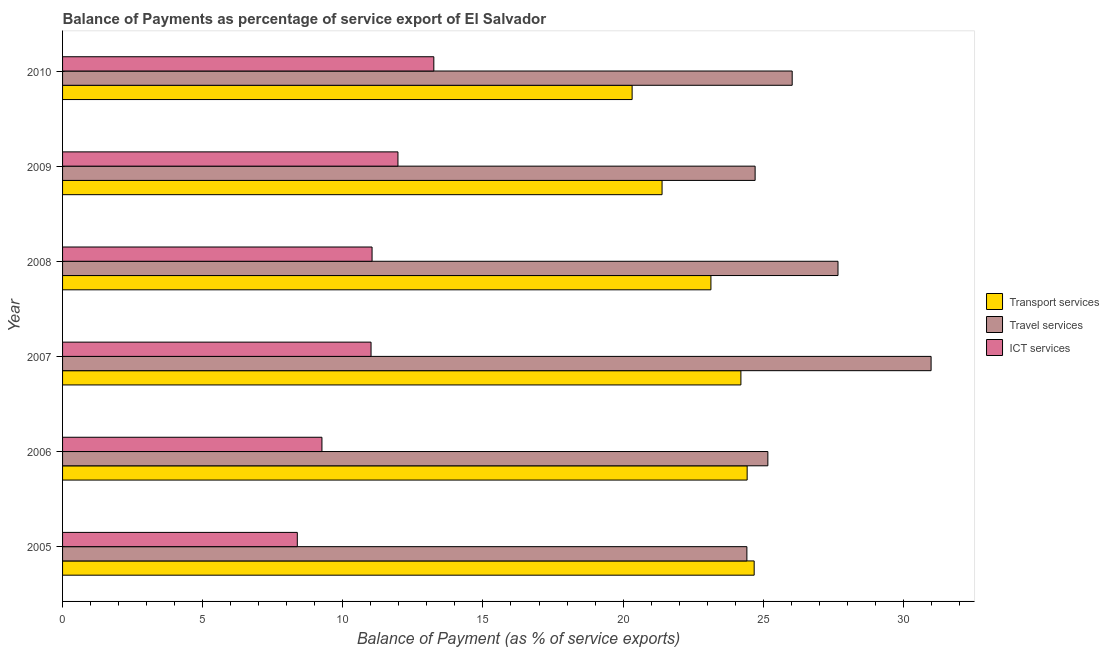How many different coloured bars are there?
Keep it short and to the point. 3. How many groups of bars are there?
Offer a terse response. 6. Are the number of bars per tick equal to the number of legend labels?
Your answer should be compact. Yes. Are the number of bars on each tick of the Y-axis equal?
Your response must be concise. Yes. How many bars are there on the 1st tick from the top?
Provide a succinct answer. 3. What is the balance of payment of travel services in 2005?
Offer a very short reply. 24.42. Across all years, what is the maximum balance of payment of transport services?
Your answer should be very brief. 24.68. Across all years, what is the minimum balance of payment of travel services?
Provide a short and direct response. 24.42. In which year was the balance of payment of ict services maximum?
Your response must be concise. 2010. In which year was the balance of payment of travel services minimum?
Ensure brevity in your answer.  2005. What is the total balance of payment of ict services in the graph?
Provide a short and direct response. 64.89. What is the difference between the balance of payment of travel services in 2006 and that in 2007?
Provide a short and direct response. -5.83. What is the difference between the balance of payment of ict services in 2006 and the balance of payment of travel services in 2009?
Your answer should be very brief. -15.46. What is the average balance of payment of ict services per year?
Provide a succinct answer. 10.82. In the year 2006, what is the difference between the balance of payment of transport services and balance of payment of travel services?
Give a very brief answer. -0.74. In how many years, is the balance of payment of travel services greater than 22 %?
Provide a short and direct response. 6. What is the ratio of the balance of payment of ict services in 2006 to that in 2007?
Provide a succinct answer. 0.84. What is the difference between the highest and the second highest balance of payment of ict services?
Your answer should be compact. 1.28. What is the difference between the highest and the lowest balance of payment of ict services?
Offer a terse response. 4.87. In how many years, is the balance of payment of transport services greater than the average balance of payment of transport services taken over all years?
Your answer should be compact. 4. What does the 3rd bar from the top in 2008 represents?
Your answer should be compact. Transport services. What does the 2nd bar from the bottom in 2006 represents?
Give a very brief answer. Travel services. How many years are there in the graph?
Make the answer very short. 6. What is the difference between two consecutive major ticks on the X-axis?
Keep it short and to the point. 5. Does the graph contain any zero values?
Provide a short and direct response. No. Does the graph contain grids?
Provide a short and direct response. No. Where does the legend appear in the graph?
Your answer should be compact. Center right. How many legend labels are there?
Offer a terse response. 3. How are the legend labels stacked?
Provide a short and direct response. Vertical. What is the title of the graph?
Keep it short and to the point. Balance of Payments as percentage of service export of El Salvador. What is the label or title of the X-axis?
Provide a short and direct response. Balance of Payment (as % of service exports). What is the Balance of Payment (as % of service exports) in Transport services in 2005?
Keep it short and to the point. 24.68. What is the Balance of Payment (as % of service exports) of Travel services in 2005?
Keep it short and to the point. 24.42. What is the Balance of Payment (as % of service exports) in ICT services in 2005?
Give a very brief answer. 8.38. What is the Balance of Payment (as % of service exports) of Transport services in 2006?
Your answer should be very brief. 24.43. What is the Balance of Payment (as % of service exports) of Travel services in 2006?
Your answer should be very brief. 25.17. What is the Balance of Payment (as % of service exports) in ICT services in 2006?
Make the answer very short. 9.25. What is the Balance of Payment (as % of service exports) in Transport services in 2007?
Give a very brief answer. 24.2. What is the Balance of Payment (as % of service exports) in Travel services in 2007?
Make the answer very short. 30.99. What is the Balance of Payment (as % of service exports) of ICT services in 2007?
Give a very brief answer. 11.01. What is the Balance of Payment (as % of service exports) in Transport services in 2008?
Ensure brevity in your answer.  23.13. What is the Balance of Payment (as % of service exports) in Travel services in 2008?
Ensure brevity in your answer.  27.67. What is the Balance of Payment (as % of service exports) in ICT services in 2008?
Offer a very short reply. 11.04. What is the Balance of Payment (as % of service exports) in Transport services in 2009?
Provide a succinct answer. 21.39. What is the Balance of Payment (as % of service exports) in Travel services in 2009?
Your answer should be very brief. 24.71. What is the Balance of Payment (as % of service exports) in ICT services in 2009?
Keep it short and to the point. 11.97. What is the Balance of Payment (as % of service exports) of Transport services in 2010?
Your response must be concise. 20.32. What is the Balance of Payment (as % of service exports) in Travel services in 2010?
Provide a succinct answer. 26.03. What is the Balance of Payment (as % of service exports) in ICT services in 2010?
Provide a short and direct response. 13.25. Across all years, what is the maximum Balance of Payment (as % of service exports) of Transport services?
Provide a succinct answer. 24.68. Across all years, what is the maximum Balance of Payment (as % of service exports) of Travel services?
Provide a short and direct response. 30.99. Across all years, what is the maximum Balance of Payment (as % of service exports) in ICT services?
Your response must be concise. 13.25. Across all years, what is the minimum Balance of Payment (as % of service exports) in Transport services?
Ensure brevity in your answer.  20.32. Across all years, what is the minimum Balance of Payment (as % of service exports) of Travel services?
Keep it short and to the point. 24.42. Across all years, what is the minimum Balance of Payment (as % of service exports) of ICT services?
Provide a succinct answer. 8.38. What is the total Balance of Payment (as % of service exports) of Transport services in the graph?
Keep it short and to the point. 138.15. What is the total Balance of Payment (as % of service exports) of Travel services in the graph?
Provide a succinct answer. 158.99. What is the total Balance of Payment (as % of service exports) in ICT services in the graph?
Keep it short and to the point. 64.89. What is the difference between the Balance of Payment (as % of service exports) of Transport services in 2005 and that in 2006?
Your answer should be very brief. 0.25. What is the difference between the Balance of Payment (as % of service exports) in Travel services in 2005 and that in 2006?
Provide a short and direct response. -0.75. What is the difference between the Balance of Payment (as % of service exports) of ICT services in 2005 and that in 2006?
Offer a terse response. -0.88. What is the difference between the Balance of Payment (as % of service exports) in Transport services in 2005 and that in 2007?
Your answer should be compact. 0.47. What is the difference between the Balance of Payment (as % of service exports) in Travel services in 2005 and that in 2007?
Your answer should be very brief. -6.57. What is the difference between the Balance of Payment (as % of service exports) of ICT services in 2005 and that in 2007?
Keep it short and to the point. -2.63. What is the difference between the Balance of Payment (as % of service exports) in Transport services in 2005 and that in 2008?
Provide a short and direct response. 1.54. What is the difference between the Balance of Payment (as % of service exports) in Travel services in 2005 and that in 2008?
Your answer should be very brief. -3.25. What is the difference between the Balance of Payment (as % of service exports) in ICT services in 2005 and that in 2008?
Your answer should be compact. -2.67. What is the difference between the Balance of Payment (as % of service exports) in Transport services in 2005 and that in 2009?
Your answer should be very brief. 3.29. What is the difference between the Balance of Payment (as % of service exports) of Travel services in 2005 and that in 2009?
Provide a succinct answer. -0.29. What is the difference between the Balance of Payment (as % of service exports) of ICT services in 2005 and that in 2009?
Make the answer very short. -3.59. What is the difference between the Balance of Payment (as % of service exports) of Transport services in 2005 and that in 2010?
Offer a very short reply. 4.36. What is the difference between the Balance of Payment (as % of service exports) in Travel services in 2005 and that in 2010?
Keep it short and to the point. -1.62. What is the difference between the Balance of Payment (as % of service exports) in ICT services in 2005 and that in 2010?
Offer a very short reply. -4.87. What is the difference between the Balance of Payment (as % of service exports) of Transport services in 2006 and that in 2007?
Provide a short and direct response. 0.22. What is the difference between the Balance of Payment (as % of service exports) of Travel services in 2006 and that in 2007?
Provide a short and direct response. -5.82. What is the difference between the Balance of Payment (as % of service exports) in ICT services in 2006 and that in 2007?
Provide a succinct answer. -1.75. What is the difference between the Balance of Payment (as % of service exports) in Transport services in 2006 and that in 2008?
Your answer should be compact. 1.29. What is the difference between the Balance of Payment (as % of service exports) in Travel services in 2006 and that in 2008?
Provide a short and direct response. -2.5. What is the difference between the Balance of Payment (as % of service exports) of ICT services in 2006 and that in 2008?
Offer a very short reply. -1.79. What is the difference between the Balance of Payment (as % of service exports) in Transport services in 2006 and that in 2009?
Ensure brevity in your answer.  3.04. What is the difference between the Balance of Payment (as % of service exports) of Travel services in 2006 and that in 2009?
Give a very brief answer. 0.45. What is the difference between the Balance of Payment (as % of service exports) of ICT services in 2006 and that in 2009?
Your answer should be very brief. -2.71. What is the difference between the Balance of Payment (as % of service exports) of Transport services in 2006 and that in 2010?
Ensure brevity in your answer.  4.1. What is the difference between the Balance of Payment (as % of service exports) of Travel services in 2006 and that in 2010?
Provide a short and direct response. -0.87. What is the difference between the Balance of Payment (as % of service exports) of ICT services in 2006 and that in 2010?
Offer a terse response. -3.99. What is the difference between the Balance of Payment (as % of service exports) of Transport services in 2007 and that in 2008?
Your answer should be compact. 1.07. What is the difference between the Balance of Payment (as % of service exports) in Travel services in 2007 and that in 2008?
Offer a terse response. 3.32. What is the difference between the Balance of Payment (as % of service exports) of ICT services in 2007 and that in 2008?
Keep it short and to the point. -0.04. What is the difference between the Balance of Payment (as % of service exports) of Transport services in 2007 and that in 2009?
Your answer should be compact. 2.81. What is the difference between the Balance of Payment (as % of service exports) in Travel services in 2007 and that in 2009?
Provide a short and direct response. 6.28. What is the difference between the Balance of Payment (as % of service exports) in ICT services in 2007 and that in 2009?
Your response must be concise. -0.96. What is the difference between the Balance of Payment (as % of service exports) in Transport services in 2007 and that in 2010?
Make the answer very short. 3.88. What is the difference between the Balance of Payment (as % of service exports) of Travel services in 2007 and that in 2010?
Ensure brevity in your answer.  4.96. What is the difference between the Balance of Payment (as % of service exports) of ICT services in 2007 and that in 2010?
Ensure brevity in your answer.  -2.24. What is the difference between the Balance of Payment (as % of service exports) of Transport services in 2008 and that in 2009?
Your response must be concise. 1.74. What is the difference between the Balance of Payment (as % of service exports) of Travel services in 2008 and that in 2009?
Your response must be concise. 2.96. What is the difference between the Balance of Payment (as % of service exports) in ICT services in 2008 and that in 2009?
Your answer should be compact. -0.92. What is the difference between the Balance of Payment (as % of service exports) of Transport services in 2008 and that in 2010?
Keep it short and to the point. 2.81. What is the difference between the Balance of Payment (as % of service exports) in Travel services in 2008 and that in 2010?
Provide a short and direct response. 1.63. What is the difference between the Balance of Payment (as % of service exports) in ICT services in 2008 and that in 2010?
Your answer should be very brief. -2.2. What is the difference between the Balance of Payment (as % of service exports) in Transport services in 2009 and that in 2010?
Provide a succinct answer. 1.07. What is the difference between the Balance of Payment (as % of service exports) of Travel services in 2009 and that in 2010?
Your response must be concise. -1.32. What is the difference between the Balance of Payment (as % of service exports) of ICT services in 2009 and that in 2010?
Provide a succinct answer. -1.28. What is the difference between the Balance of Payment (as % of service exports) of Transport services in 2005 and the Balance of Payment (as % of service exports) of Travel services in 2006?
Make the answer very short. -0.49. What is the difference between the Balance of Payment (as % of service exports) of Transport services in 2005 and the Balance of Payment (as % of service exports) of ICT services in 2006?
Give a very brief answer. 15.42. What is the difference between the Balance of Payment (as % of service exports) of Travel services in 2005 and the Balance of Payment (as % of service exports) of ICT services in 2006?
Ensure brevity in your answer.  15.16. What is the difference between the Balance of Payment (as % of service exports) of Transport services in 2005 and the Balance of Payment (as % of service exports) of Travel services in 2007?
Your answer should be compact. -6.31. What is the difference between the Balance of Payment (as % of service exports) in Transport services in 2005 and the Balance of Payment (as % of service exports) in ICT services in 2007?
Ensure brevity in your answer.  13.67. What is the difference between the Balance of Payment (as % of service exports) of Travel services in 2005 and the Balance of Payment (as % of service exports) of ICT services in 2007?
Your answer should be compact. 13.41. What is the difference between the Balance of Payment (as % of service exports) in Transport services in 2005 and the Balance of Payment (as % of service exports) in Travel services in 2008?
Your answer should be compact. -2.99. What is the difference between the Balance of Payment (as % of service exports) of Transport services in 2005 and the Balance of Payment (as % of service exports) of ICT services in 2008?
Offer a terse response. 13.63. What is the difference between the Balance of Payment (as % of service exports) of Travel services in 2005 and the Balance of Payment (as % of service exports) of ICT services in 2008?
Provide a short and direct response. 13.37. What is the difference between the Balance of Payment (as % of service exports) in Transport services in 2005 and the Balance of Payment (as % of service exports) in Travel services in 2009?
Give a very brief answer. -0.03. What is the difference between the Balance of Payment (as % of service exports) of Transport services in 2005 and the Balance of Payment (as % of service exports) of ICT services in 2009?
Give a very brief answer. 12.71. What is the difference between the Balance of Payment (as % of service exports) in Travel services in 2005 and the Balance of Payment (as % of service exports) in ICT services in 2009?
Provide a succinct answer. 12.45. What is the difference between the Balance of Payment (as % of service exports) of Transport services in 2005 and the Balance of Payment (as % of service exports) of Travel services in 2010?
Give a very brief answer. -1.36. What is the difference between the Balance of Payment (as % of service exports) in Transport services in 2005 and the Balance of Payment (as % of service exports) in ICT services in 2010?
Your answer should be very brief. 11.43. What is the difference between the Balance of Payment (as % of service exports) of Travel services in 2005 and the Balance of Payment (as % of service exports) of ICT services in 2010?
Offer a very short reply. 11.17. What is the difference between the Balance of Payment (as % of service exports) in Transport services in 2006 and the Balance of Payment (as % of service exports) in Travel services in 2007?
Make the answer very short. -6.56. What is the difference between the Balance of Payment (as % of service exports) of Transport services in 2006 and the Balance of Payment (as % of service exports) of ICT services in 2007?
Your answer should be very brief. 13.42. What is the difference between the Balance of Payment (as % of service exports) in Travel services in 2006 and the Balance of Payment (as % of service exports) in ICT services in 2007?
Provide a short and direct response. 14.16. What is the difference between the Balance of Payment (as % of service exports) in Transport services in 2006 and the Balance of Payment (as % of service exports) in Travel services in 2008?
Ensure brevity in your answer.  -3.24. What is the difference between the Balance of Payment (as % of service exports) in Transport services in 2006 and the Balance of Payment (as % of service exports) in ICT services in 2008?
Your response must be concise. 13.38. What is the difference between the Balance of Payment (as % of service exports) of Travel services in 2006 and the Balance of Payment (as % of service exports) of ICT services in 2008?
Provide a succinct answer. 14.12. What is the difference between the Balance of Payment (as % of service exports) in Transport services in 2006 and the Balance of Payment (as % of service exports) in Travel services in 2009?
Provide a short and direct response. -0.28. What is the difference between the Balance of Payment (as % of service exports) of Transport services in 2006 and the Balance of Payment (as % of service exports) of ICT services in 2009?
Your answer should be compact. 12.46. What is the difference between the Balance of Payment (as % of service exports) in Travel services in 2006 and the Balance of Payment (as % of service exports) in ICT services in 2009?
Provide a short and direct response. 13.2. What is the difference between the Balance of Payment (as % of service exports) in Transport services in 2006 and the Balance of Payment (as % of service exports) in Travel services in 2010?
Provide a succinct answer. -1.61. What is the difference between the Balance of Payment (as % of service exports) in Transport services in 2006 and the Balance of Payment (as % of service exports) in ICT services in 2010?
Your answer should be very brief. 11.18. What is the difference between the Balance of Payment (as % of service exports) of Travel services in 2006 and the Balance of Payment (as % of service exports) of ICT services in 2010?
Your response must be concise. 11.92. What is the difference between the Balance of Payment (as % of service exports) of Transport services in 2007 and the Balance of Payment (as % of service exports) of Travel services in 2008?
Your answer should be compact. -3.46. What is the difference between the Balance of Payment (as % of service exports) of Transport services in 2007 and the Balance of Payment (as % of service exports) of ICT services in 2008?
Offer a terse response. 13.16. What is the difference between the Balance of Payment (as % of service exports) of Travel services in 2007 and the Balance of Payment (as % of service exports) of ICT services in 2008?
Offer a terse response. 19.95. What is the difference between the Balance of Payment (as % of service exports) in Transport services in 2007 and the Balance of Payment (as % of service exports) in Travel services in 2009?
Offer a terse response. -0.51. What is the difference between the Balance of Payment (as % of service exports) in Transport services in 2007 and the Balance of Payment (as % of service exports) in ICT services in 2009?
Provide a succinct answer. 12.24. What is the difference between the Balance of Payment (as % of service exports) of Travel services in 2007 and the Balance of Payment (as % of service exports) of ICT services in 2009?
Offer a terse response. 19.02. What is the difference between the Balance of Payment (as % of service exports) of Transport services in 2007 and the Balance of Payment (as % of service exports) of Travel services in 2010?
Your answer should be very brief. -1.83. What is the difference between the Balance of Payment (as % of service exports) of Transport services in 2007 and the Balance of Payment (as % of service exports) of ICT services in 2010?
Keep it short and to the point. 10.96. What is the difference between the Balance of Payment (as % of service exports) in Travel services in 2007 and the Balance of Payment (as % of service exports) in ICT services in 2010?
Make the answer very short. 17.74. What is the difference between the Balance of Payment (as % of service exports) of Transport services in 2008 and the Balance of Payment (as % of service exports) of Travel services in 2009?
Provide a succinct answer. -1.58. What is the difference between the Balance of Payment (as % of service exports) of Transport services in 2008 and the Balance of Payment (as % of service exports) of ICT services in 2009?
Offer a terse response. 11.17. What is the difference between the Balance of Payment (as % of service exports) in Travel services in 2008 and the Balance of Payment (as % of service exports) in ICT services in 2009?
Offer a terse response. 15.7. What is the difference between the Balance of Payment (as % of service exports) of Transport services in 2008 and the Balance of Payment (as % of service exports) of Travel services in 2010?
Your answer should be compact. -2.9. What is the difference between the Balance of Payment (as % of service exports) in Transport services in 2008 and the Balance of Payment (as % of service exports) in ICT services in 2010?
Keep it short and to the point. 9.89. What is the difference between the Balance of Payment (as % of service exports) of Travel services in 2008 and the Balance of Payment (as % of service exports) of ICT services in 2010?
Make the answer very short. 14.42. What is the difference between the Balance of Payment (as % of service exports) of Transport services in 2009 and the Balance of Payment (as % of service exports) of Travel services in 2010?
Your response must be concise. -4.64. What is the difference between the Balance of Payment (as % of service exports) of Transport services in 2009 and the Balance of Payment (as % of service exports) of ICT services in 2010?
Make the answer very short. 8.14. What is the difference between the Balance of Payment (as % of service exports) in Travel services in 2009 and the Balance of Payment (as % of service exports) in ICT services in 2010?
Your response must be concise. 11.46. What is the average Balance of Payment (as % of service exports) in Transport services per year?
Provide a succinct answer. 23.03. What is the average Balance of Payment (as % of service exports) in Travel services per year?
Provide a short and direct response. 26.5. What is the average Balance of Payment (as % of service exports) of ICT services per year?
Ensure brevity in your answer.  10.82. In the year 2005, what is the difference between the Balance of Payment (as % of service exports) in Transport services and Balance of Payment (as % of service exports) in Travel services?
Provide a succinct answer. 0.26. In the year 2005, what is the difference between the Balance of Payment (as % of service exports) in Transport services and Balance of Payment (as % of service exports) in ICT services?
Ensure brevity in your answer.  16.3. In the year 2005, what is the difference between the Balance of Payment (as % of service exports) in Travel services and Balance of Payment (as % of service exports) in ICT services?
Ensure brevity in your answer.  16.04. In the year 2006, what is the difference between the Balance of Payment (as % of service exports) in Transport services and Balance of Payment (as % of service exports) in Travel services?
Ensure brevity in your answer.  -0.74. In the year 2006, what is the difference between the Balance of Payment (as % of service exports) in Transport services and Balance of Payment (as % of service exports) in ICT services?
Your answer should be compact. 15.17. In the year 2006, what is the difference between the Balance of Payment (as % of service exports) in Travel services and Balance of Payment (as % of service exports) in ICT services?
Provide a succinct answer. 15.91. In the year 2007, what is the difference between the Balance of Payment (as % of service exports) of Transport services and Balance of Payment (as % of service exports) of Travel services?
Your answer should be compact. -6.79. In the year 2007, what is the difference between the Balance of Payment (as % of service exports) in Transport services and Balance of Payment (as % of service exports) in ICT services?
Your answer should be compact. 13.2. In the year 2007, what is the difference between the Balance of Payment (as % of service exports) of Travel services and Balance of Payment (as % of service exports) of ICT services?
Keep it short and to the point. 19.98. In the year 2008, what is the difference between the Balance of Payment (as % of service exports) in Transport services and Balance of Payment (as % of service exports) in Travel services?
Your answer should be compact. -4.53. In the year 2008, what is the difference between the Balance of Payment (as % of service exports) of Transport services and Balance of Payment (as % of service exports) of ICT services?
Make the answer very short. 12.09. In the year 2008, what is the difference between the Balance of Payment (as % of service exports) in Travel services and Balance of Payment (as % of service exports) in ICT services?
Provide a succinct answer. 16.63. In the year 2009, what is the difference between the Balance of Payment (as % of service exports) of Transport services and Balance of Payment (as % of service exports) of Travel services?
Your answer should be very brief. -3.32. In the year 2009, what is the difference between the Balance of Payment (as % of service exports) of Transport services and Balance of Payment (as % of service exports) of ICT services?
Offer a very short reply. 9.42. In the year 2009, what is the difference between the Balance of Payment (as % of service exports) of Travel services and Balance of Payment (as % of service exports) of ICT services?
Ensure brevity in your answer.  12.74. In the year 2010, what is the difference between the Balance of Payment (as % of service exports) in Transport services and Balance of Payment (as % of service exports) in Travel services?
Give a very brief answer. -5.71. In the year 2010, what is the difference between the Balance of Payment (as % of service exports) of Transport services and Balance of Payment (as % of service exports) of ICT services?
Your response must be concise. 7.08. In the year 2010, what is the difference between the Balance of Payment (as % of service exports) of Travel services and Balance of Payment (as % of service exports) of ICT services?
Ensure brevity in your answer.  12.79. What is the ratio of the Balance of Payment (as % of service exports) of Transport services in 2005 to that in 2006?
Your answer should be very brief. 1.01. What is the ratio of the Balance of Payment (as % of service exports) in Travel services in 2005 to that in 2006?
Keep it short and to the point. 0.97. What is the ratio of the Balance of Payment (as % of service exports) in ICT services in 2005 to that in 2006?
Provide a short and direct response. 0.91. What is the ratio of the Balance of Payment (as % of service exports) in Transport services in 2005 to that in 2007?
Make the answer very short. 1.02. What is the ratio of the Balance of Payment (as % of service exports) of Travel services in 2005 to that in 2007?
Your answer should be very brief. 0.79. What is the ratio of the Balance of Payment (as % of service exports) in ICT services in 2005 to that in 2007?
Offer a terse response. 0.76. What is the ratio of the Balance of Payment (as % of service exports) in Transport services in 2005 to that in 2008?
Give a very brief answer. 1.07. What is the ratio of the Balance of Payment (as % of service exports) of Travel services in 2005 to that in 2008?
Provide a short and direct response. 0.88. What is the ratio of the Balance of Payment (as % of service exports) in ICT services in 2005 to that in 2008?
Provide a short and direct response. 0.76. What is the ratio of the Balance of Payment (as % of service exports) in Transport services in 2005 to that in 2009?
Your answer should be compact. 1.15. What is the ratio of the Balance of Payment (as % of service exports) in Travel services in 2005 to that in 2009?
Your response must be concise. 0.99. What is the ratio of the Balance of Payment (as % of service exports) in ICT services in 2005 to that in 2009?
Your answer should be very brief. 0.7. What is the ratio of the Balance of Payment (as % of service exports) of Transport services in 2005 to that in 2010?
Your answer should be very brief. 1.21. What is the ratio of the Balance of Payment (as % of service exports) in Travel services in 2005 to that in 2010?
Your response must be concise. 0.94. What is the ratio of the Balance of Payment (as % of service exports) in ICT services in 2005 to that in 2010?
Your response must be concise. 0.63. What is the ratio of the Balance of Payment (as % of service exports) of Transport services in 2006 to that in 2007?
Offer a very short reply. 1.01. What is the ratio of the Balance of Payment (as % of service exports) in Travel services in 2006 to that in 2007?
Your answer should be very brief. 0.81. What is the ratio of the Balance of Payment (as % of service exports) of ICT services in 2006 to that in 2007?
Your answer should be compact. 0.84. What is the ratio of the Balance of Payment (as % of service exports) in Transport services in 2006 to that in 2008?
Provide a succinct answer. 1.06. What is the ratio of the Balance of Payment (as % of service exports) of Travel services in 2006 to that in 2008?
Offer a very short reply. 0.91. What is the ratio of the Balance of Payment (as % of service exports) in ICT services in 2006 to that in 2008?
Keep it short and to the point. 0.84. What is the ratio of the Balance of Payment (as % of service exports) in Transport services in 2006 to that in 2009?
Your answer should be compact. 1.14. What is the ratio of the Balance of Payment (as % of service exports) of Travel services in 2006 to that in 2009?
Ensure brevity in your answer.  1.02. What is the ratio of the Balance of Payment (as % of service exports) in ICT services in 2006 to that in 2009?
Provide a succinct answer. 0.77. What is the ratio of the Balance of Payment (as % of service exports) in Transport services in 2006 to that in 2010?
Make the answer very short. 1.2. What is the ratio of the Balance of Payment (as % of service exports) in Travel services in 2006 to that in 2010?
Give a very brief answer. 0.97. What is the ratio of the Balance of Payment (as % of service exports) of ICT services in 2006 to that in 2010?
Make the answer very short. 0.7. What is the ratio of the Balance of Payment (as % of service exports) in Transport services in 2007 to that in 2008?
Keep it short and to the point. 1.05. What is the ratio of the Balance of Payment (as % of service exports) in Travel services in 2007 to that in 2008?
Your answer should be compact. 1.12. What is the ratio of the Balance of Payment (as % of service exports) of Transport services in 2007 to that in 2009?
Ensure brevity in your answer.  1.13. What is the ratio of the Balance of Payment (as % of service exports) in Travel services in 2007 to that in 2009?
Ensure brevity in your answer.  1.25. What is the ratio of the Balance of Payment (as % of service exports) of ICT services in 2007 to that in 2009?
Make the answer very short. 0.92. What is the ratio of the Balance of Payment (as % of service exports) of Transport services in 2007 to that in 2010?
Ensure brevity in your answer.  1.19. What is the ratio of the Balance of Payment (as % of service exports) in Travel services in 2007 to that in 2010?
Your response must be concise. 1.19. What is the ratio of the Balance of Payment (as % of service exports) in ICT services in 2007 to that in 2010?
Keep it short and to the point. 0.83. What is the ratio of the Balance of Payment (as % of service exports) in Transport services in 2008 to that in 2009?
Offer a very short reply. 1.08. What is the ratio of the Balance of Payment (as % of service exports) of Travel services in 2008 to that in 2009?
Your answer should be very brief. 1.12. What is the ratio of the Balance of Payment (as % of service exports) of ICT services in 2008 to that in 2009?
Your response must be concise. 0.92. What is the ratio of the Balance of Payment (as % of service exports) in Transport services in 2008 to that in 2010?
Give a very brief answer. 1.14. What is the ratio of the Balance of Payment (as % of service exports) in Travel services in 2008 to that in 2010?
Give a very brief answer. 1.06. What is the ratio of the Balance of Payment (as % of service exports) of ICT services in 2008 to that in 2010?
Provide a short and direct response. 0.83. What is the ratio of the Balance of Payment (as % of service exports) in Transport services in 2009 to that in 2010?
Your answer should be compact. 1.05. What is the ratio of the Balance of Payment (as % of service exports) in Travel services in 2009 to that in 2010?
Your answer should be very brief. 0.95. What is the ratio of the Balance of Payment (as % of service exports) in ICT services in 2009 to that in 2010?
Offer a very short reply. 0.9. What is the difference between the highest and the second highest Balance of Payment (as % of service exports) of Transport services?
Make the answer very short. 0.25. What is the difference between the highest and the second highest Balance of Payment (as % of service exports) of Travel services?
Offer a terse response. 3.32. What is the difference between the highest and the second highest Balance of Payment (as % of service exports) of ICT services?
Offer a very short reply. 1.28. What is the difference between the highest and the lowest Balance of Payment (as % of service exports) of Transport services?
Offer a very short reply. 4.36. What is the difference between the highest and the lowest Balance of Payment (as % of service exports) in Travel services?
Offer a terse response. 6.57. What is the difference between the highest and the lowest Balance of Payment (as % of service exports) of ICT services?
Make the answer very short. 4.87. 